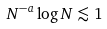<formula> <loc_0><loc_0><loc_500><loc_500>N ^ { - a } \log N \lesssim 1</formula> 